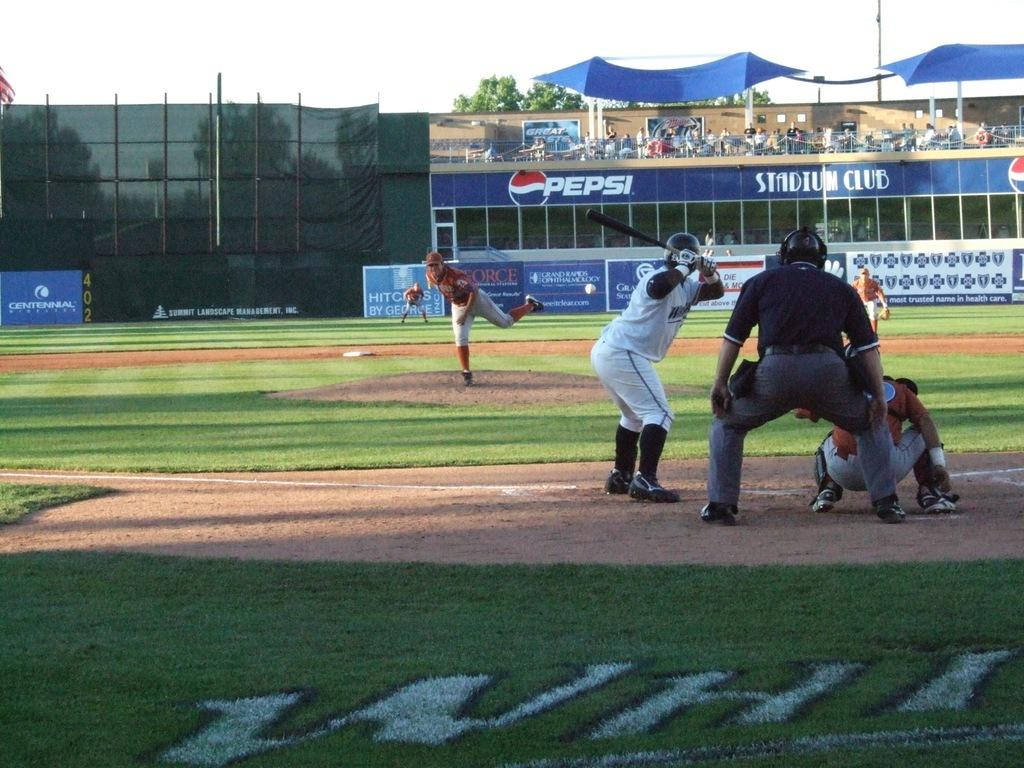<image>
Render a clear and concise summary of the photo. People playing baseball in a stadium with an ad for Pepsi. 